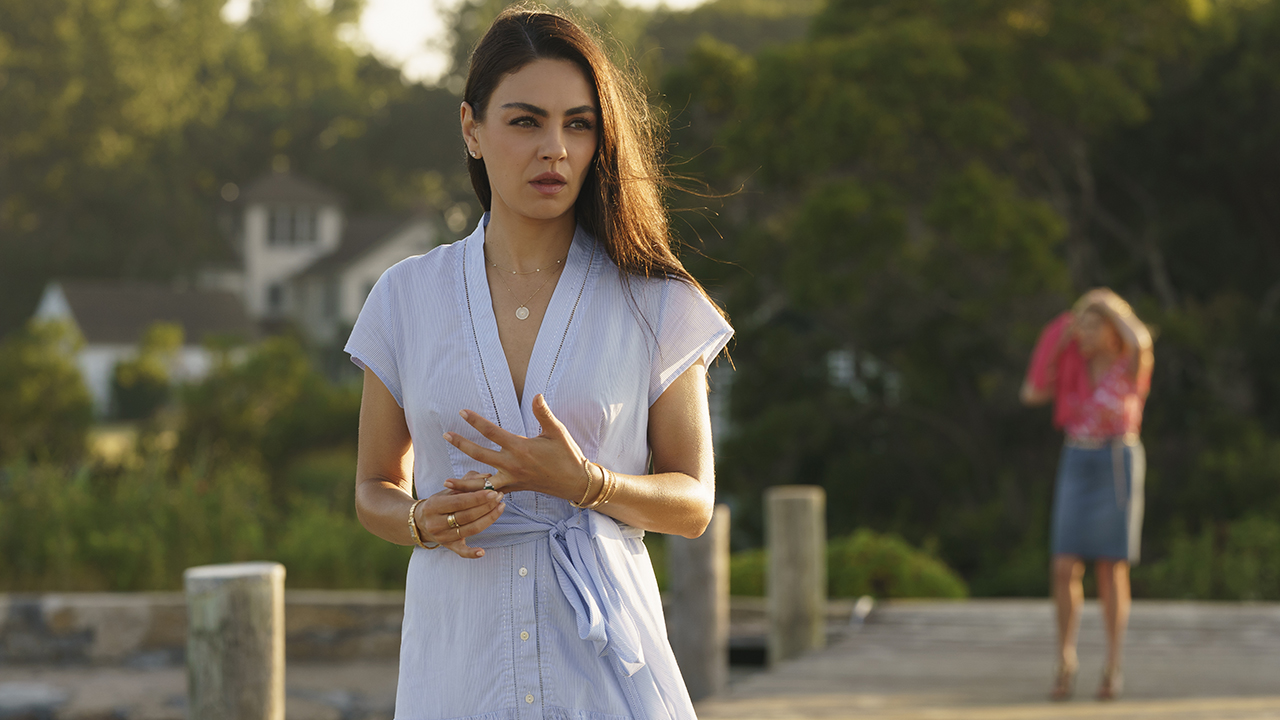Describe the mood of the scene in the image. The mood of the scene is introspective and serene. The woman in the foreground appears to be lost in thought, suggested by her contemplative expression and the way she clasps her hands. The soft light of what seems to be either morning or late afternoon adds a warm glow to the scene, enhancing the peaceful atmosphere. The background, with its lush greenery and a house visible in the distance, contributes to a sense of calm and tranquility. The presence of another woman walking away from the pier adds a layer of narrative curiosity, making one wonder about the relationship between the two women and the nature of their thoughts and emotions. What do you think the woman in the foreground might be thinking about? The woman in the foreground could be pondering a variety of things. Given her introspective expression and quiet demeanor, she might be reflecting on a significant life event, considering an important decision, or simply enjoying a moment of solitude by the water. The way she stands, with her hands clasped and her gaze turned away from the camera, suggests a depth of thought perhaps connected to personal or emotional matters. The peaceful and natural setting might also inspire thoughts about nature, life, or future aspirations. 